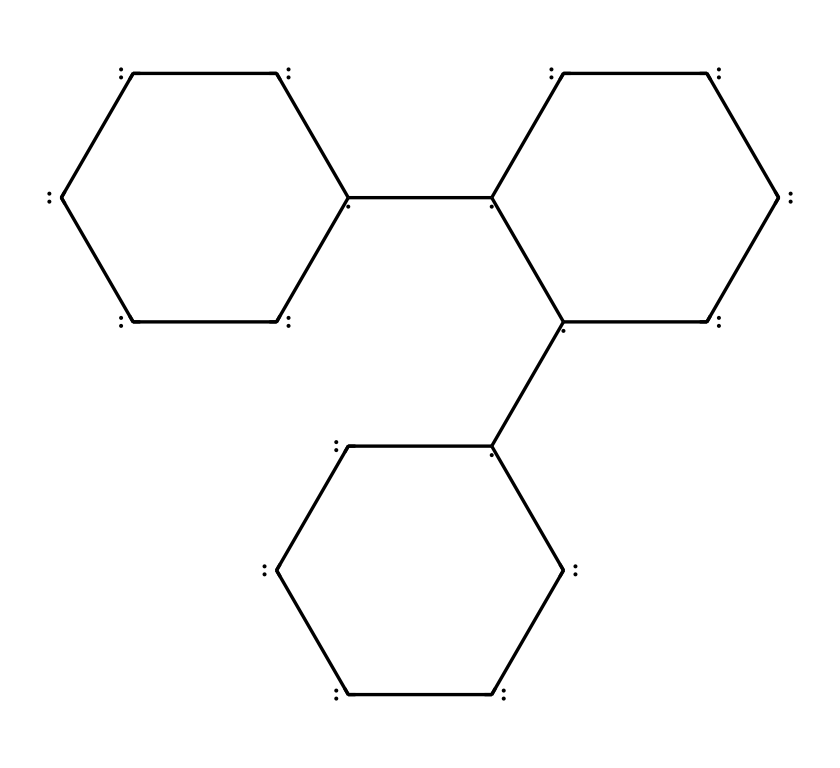what is the central element in the chemical structure? The SMILES representation indicates that the chemical structure consists primarily of carbon atoms, as denoted by the letter "C" in the notation.
Answer: carbon how many carbon atoms are present in the molecule? By counting each occurrence of "C" in the SMILES string, we find a total of 30 carbon atoms represented.
Answer: 30 what type of nanomaterial is represented by this structure? The depicted structure is characteristic of carbon nanotubes, which are a type of nanomaterial known for their unique properties and applications in various fields including advanced filtration.
Answer: carbon nanotubes what is one notable property of carbon nanotubes related to filtration? Carbon nanotubes are known for their exceptional permeability, allowing water to pass through while filtering out larger contaminants effectively, which enhances their capacity in filtration systems.
Answer: permeability how many rings are present in this structure? The structure contains three distinct cyclic arrangements of carbon atoms, each indicated by the cyclic structure shown in the SMILES.
Answer: 3 what role do carbon nanotubes play in water filtration systems? In water filtration systems, carbon nanotubes act as effective adsorbents, which help to remove impurities and contaminants from water due to their high surface area and reactivity.
Answer: adsorbents 